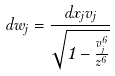Convert formula to latex. <formula><loc_0><loc_0><loc_500><loc_500>d w _ { j } = \frac { d x _ { j } v _ { j } } { \sqrt { 1 - \frac { v _ { j } ^ { 6 } } { z ^ { 6 } } } }</formula> 